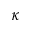<formula> <loc_0><loc_0><loc_500><loc_500>\kappa</formula> 